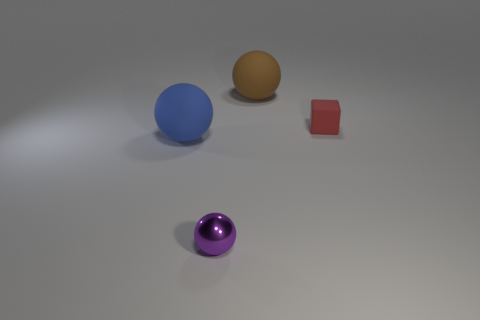Add 4 small yellow rubber balls. How many objects exist? 8 Subtract all brown spheres. How many spheres are left? 2 Subtract all cubes. How many objects are left? 3 Subtract 1 cubes. How many cubes are left? 0 Subtract all blue cylinders. How many brown spheres are left? 1 Subtract all big brown spheres. Subtract all tiny red cubes. How many objects are left? 2 Add 4 small rubber blocks. How many small rubber blocks are left? 5 Add 4 tiny purple shiny objects. How many tiny purple shiny objects exist? 5 Subtract all blue spheres. How many spheres are left? 2 Subtract 0 yellow blocks. How many objects are left? 4 